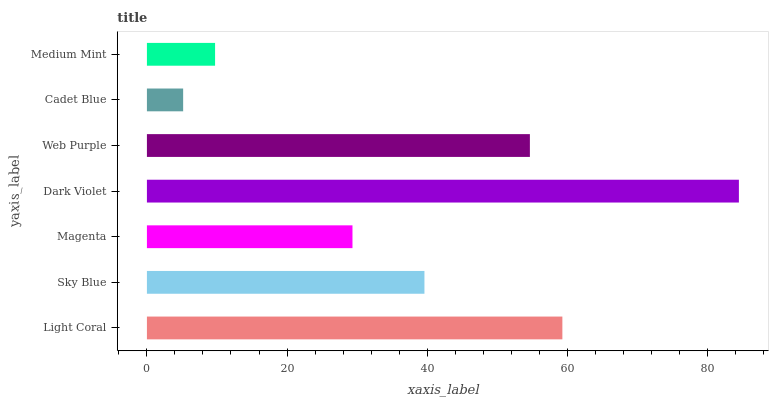Is Cadet Blue the minimum?
Answer yes or no. Yes. Is Dark Violet the maximum?
Answer yes or no. Yes. Is Sky Blue the minimum?
Answer yes or no. No. Is Sky Blue the maximum?
Answer yes or no. No. Is Light Coral greater than Sky Blue?
Answer yes or no. Yes. Is Sky Blue less than Light Coral?
Answer yes or no. Yes. Is Sky Blue greater than Light Coral?
Answer yes or no. No. Is Light Coral less than Sky Blue?
Answer yes or no. No. Is Sky Blue the high median?
Answer yes or no. Yes. Is Sky Blue the low median?
Answer yes or no. Yes. Is Web Purple the high median?
Answer yes or no. No. Is Cadet Blue the low median?
Answer yes or no. No. 